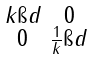Convert formula to latex. <formula><loc_0><loc_0><loc_500><loc_500>\begin{smallmatrix} k \i d & 0 \\ 0 & \frac { 1 } { k } \i d \end{smallmatrix}</formula> 